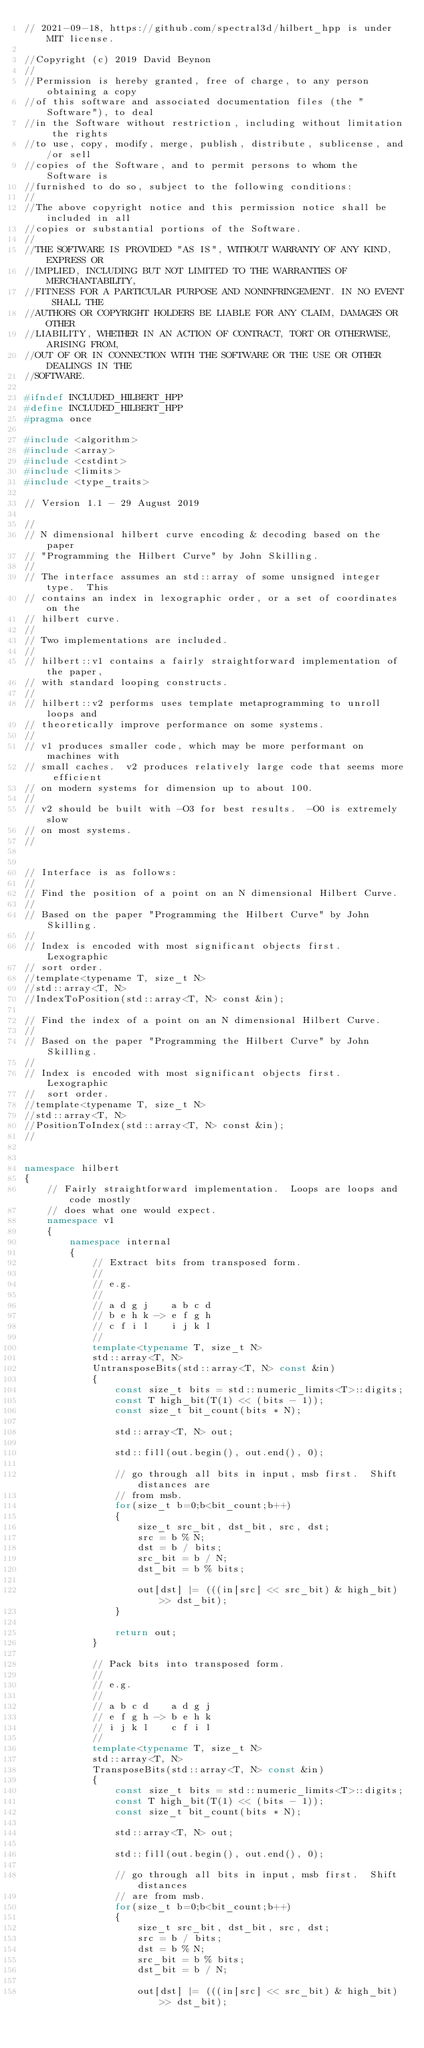<code> <loc_0><loc_0><loc_500><loc_500><_C++_>// 2021-09-18, https://github.com/spectral3d/hilbert_hpp is under MIT license.

//Copyright (c) 2019 David Beynon
//
//Permission is hereby granted, free of charge, to any person obtaining a copy
//of this software and associated documentation files (the "Software"), to deal
//in the Software without restriction, including without limitation the rights
//to use, copy, modify, merge, publish, distribute, sublicense, and/or sell
//copies of the Software, and to permit persons to whom the Software is
//furnished to do so, subject to the following conditions:
//
//The above copyright notice and this permission notice shall be included in all
//copies or substantial portions of the Software.
//
//THE SOFTWARE IS PROVIDED "AS IS", WITHOUT WARRANTY OF ANY KIND, EXPRESS OR
//IMPLIED, INCLUDING BUT NOT LIMITED TO THE WARRANTIES OF MERCHANTABILITY,
//FITNESS FOR A PARTICULAR PURPOSE AND NONINFRINGEMENT. IN NO EVENT SHALL THE
//AUTHORS OR COPYRIGHT HOLDERS BE LIABLE FOR ANY CLAIM, DAMAGES OR OTHER
//LIABILITY, WHETHER IN AN ACTION OF CONTRACT, TORT OR OTHERWISE, ARISING FROM,
//OUT OF OR IN CONNECTION WITH THE SOFTWARE OR THE USE OR OTHER DEALINGS IN THE
//SOFTWARE.

#ifndef INCLUDED_HILBERT_HPP
#define INCLUDED_HILBERT_HPP
#pragma once

#include <algorithm>
#include <array>
#include <cstdint>
#include <limits>
#include <type_traits>

// Version 1.1 - 29 August 2019

//
// N dimensional hilbert curve encoding & decoding based on the paper
// "Programming the Hilbert Curve" by John Skilling.
//
// The interface assumes an std::array of some unsigned integer type.  This
// contains an index in lexographic order, or a set of coordinates on the
// hilbert curve.
//
// Two implementations are included.
//
// hilbert::v1 contains a fairly straightforward implementation of the paper,
// with standard looping constructs.
//
// hilbert::v2 performs uses template metaprogramming to unroll loops and
// theoretically improve performance on some systems.
//
// v1 produces smaller code, which may be more performant on machines with
// small caches.  v2 produces relatively large code that seems more efficient
// on modern systems for dimension up to about 100.
//
// v2 should be built with -O3 for best results.  -O0 is extremely slow
// on most systems.
//


// Interface is as follows:
//
// Find the position of a point on an N dimensional Hilbert Curve.
//
// Based on the paper "Programming the Hilbert Curve" by John Skilling.
//
// Index is encoded with most significant objects first.  Lexographic
// sort order.
//template<typename T, size_t N>
//std::array<T, N>
//IndexToPosition(std::array<T, N> const &in);

// Find the index of a point on an N dimensional Hilbert Curve.
//
// Based on the paper "Programming the Hilbert Curve" by John Skilling.
//
// Index is encoded with most significant objects first.  Lexographic
//  sort order.
//template<typename T, size_t N>
//std::array<T, N>
//PositionToIndex(std::array<T, N> const &in);
//


namespace hilbert
{
    // Fairly straightforward implementation.  Loops are loops and code mostly
    // does what one would expect.
    namespace v1
    {
        namespace internal
        {
            // Extract bits from transposed form.
            //
            // e.g.
            //
            // a d g j    a b c d
            // b e h k -> e f g h
            // c f i l    i j k l
            //
            template<typename T, size_t N>
            std::array<T, N>
            UntransposeBits(std::array<T, N> const &in)
            {
                const size_t bits = std::numeric_limits<T>::digits;
                const T high_bit(T(1) << (bits - 1));
                const size_t bit_count(bits * N);

                std::array<T, N> out;

                std::fill(out.begin(), out.end(), 0);

                // go through all bits in input, msb first.  Shift distances are
                // from msb.
                for(size_t b=0;b<bit_count;b++)
                {
                    size_t src_bit, dst_bit, src, dst;
                    src = b % N;
                    dst = b / bits;
                    src_bit = b / N;
                    dst_bit = b % bits;

                    out[dst] |= (((in[src] << src_bit) & high_bit) >> dst_bit);
                }

                return out;
            }

            // Pack bits into transposed form.
            //
            // e.g.
            //
            // a b c d    a d g j
            // e f g h -> b e h k
            // i j k l    c f i l
            //
            template<typename T, size_t N>
            std::array<T, N>
            TransposeBits(std::array<T, N> const &in)
            {
                const size_t bits = std::numeric_limits<T>::digits;
                const T high_bit(T(1) << (bits - 1));
                const size_t bit_count(bits * N);

                std::array<T, N> out;

                std::fill(out.begin(), out.end(), 0);

                // go through all bits in input, msb first.  Shift distances
                // are from msb.
                for(size_t b=0;b<bit_count;b++)
                {
                    size_t src_bit, dst_bit, src, dst;
                    src = b / bits;
                    dst = b % N;
                    src_bit = b % bits;
                    dst_bit = b / N;

                    out[dst] |= (((in[src] << src_bit) & high_bit) >> dst_bit);</code> 